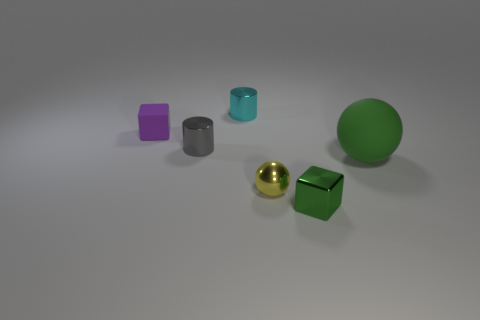Do the shiny cylinder behind the tiny gray metallic thing and the purple matte cube that is to the left of the shiny block have the same size?
Your response must be concise. Yes. Is there another green thing of the same shape as the small matte object?
Offer a very short reply. Yes. Is the number of green things on the left side of the small gray metal cylinder less than the number of blue cubes?
Give a very brief answer. No. Does the gray object have the same shape as the large green matte object?
Provide a short and direct response. No. How big is the matte object that is to the right of the small ball?
Provide a succinct answer. Large. There is a ball that is made of the same material as the purple object; what is its size?
Offer a very short reply. Large. Is the number of large cyan balls less than the number of large green things?
Your response must be concise. Yes. What material is the purple thing that is the same size as the yellow metallic sphere?
Your answer should be compact. Rubber. Are there more big rubber spheres than big gray matte cylinders?
Provide a short and direct response. Yes. What number of other things are there of the same color as the small matte cube?
Your answer should be very brief. 0. 